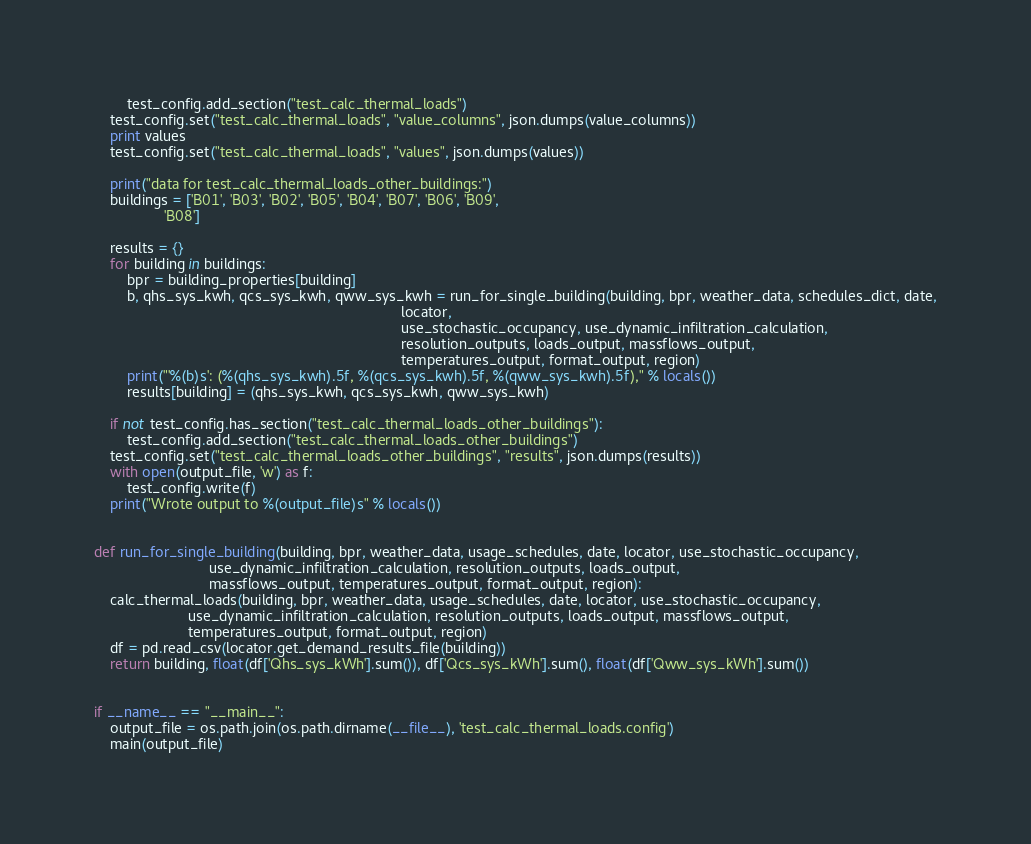Convert code to text. <code><loc_0><loc_0><loc_500><loc_500><_Python_>        test_config.add_section("test_calc_thermal_loads")
    test_config.set("test_calc_thermal_loads", "value_columns", json.dumps(value_columns))
    print values
    test_config.set("test_calc_thermal_loads", "values", json.dumps(values))

    print("data for test_calc_thermal_loads_other_buildings:")
    buildings = ['B01', 'B03', 'B02', 'B05', 'B04', 'B07', 'B06', 'B09',
                 'B08']

    results = {}
    for building in buildings:
        bpr = building_properties[building]
        b, qhs_sys_kwh, qcs_sys_kwh, qww_sys_kwh = run_for_single_building(building, bpr, weather_data, schedules_dict, date,
                                                                           locator,
                                                                           use_stochastic_occupancy, use_dynamic_infiltration_calculation,
                                                                           resolution_outputs, loads_output, massflows_output,
                                                                           temperatures_output, format_output, region)
        print("'%(b)s': (%(qhs_sys_kwh).5f, %(qcs_sys_kwh).5f, %(qww_sys_kwh).5f)," % locals())
        results[building] = (qhs_sys_kwh, qcs_sys_kwh, qww_sys_kwh)

    if not test_config.has_section("test_calc_thermal_loads_other_buildings"):
        test_config.add_section("test_calc_thermal_loads_other_buildings")
    test_config.set("test_calc_thermal_loads_other_buildings", "results", json.dumps(results))
    with open(output_file, 'w') as f:
        test_config.write(f)
    print("Wrote output to %(output_file)s" % locals())


def run_for_single_building(building, bpr, weather_data, usage_schedules, date, locator, use_stochastic_occupancy,
                            use_dynamic_infiltration_calculation, resolution_outputs, loads_output,
                            massflows_output, temperatures_output, format_output, region):
    calc_thermal_loads(building, bpr, weather_data, usage_schedules, date, locator, use_stochastic_occupancy,
                       use_dynamic_infiltration_calculation, resolution_outputs, loads_output, massflows_output,
                       temperatures_output, format_output, region)
    df = pd.read_csv(locator.get_demand_results_file(building))
    return building, float(df['Qhs_sys_kWh'].sum()), df['Qcs_sys_kWh'].sum(), float(df['Qww_sys_kWh'].sum())


if __name__ == "__main__":
    output_file = os.path.join(os.path.dirname(__file__), 'test_calc_thermal_loads.config')
    main(output_file)
</code> 